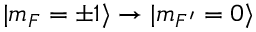<formula> <loc_0><loc_0><loc_500><loc_500>| m _ { F } = \pm 1 \rangle \rightarrow | m _ { F ^ { \prime } } = 0 \rangle</formula> 